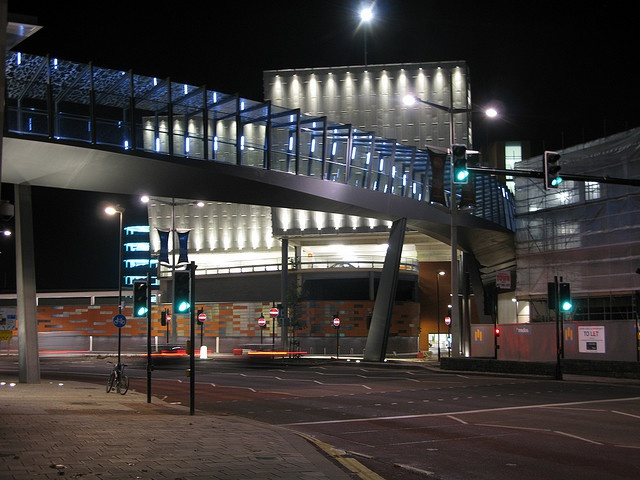Describe the objects in this image and their specific colors. I can see traffic light in black, teal, gray, and white tones, traffic light in black, gray, teal, and white tones, traffic light in black, teal, white, and gray tones, bicycle in black and gray tones, and traffic light in black, gray, darkgray, and ivory tones in this image. 